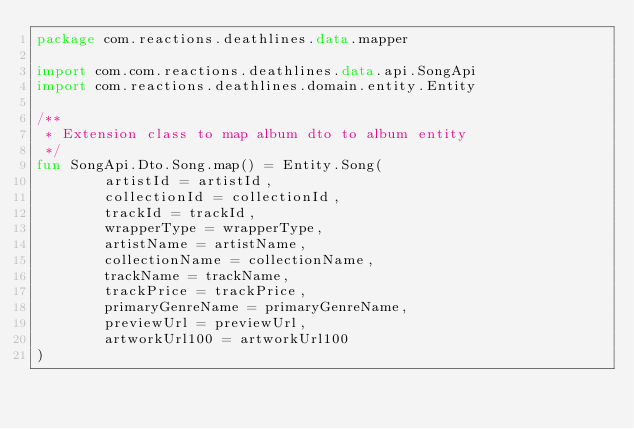<code> <loc_0><loc_0><loc_500><loc_500><_Kotlin_>package com.reactions.deathlines.data.mapper

import com.com.reactions.deathlines.data.api.SongApi
import com.reactions.deathlines.domain.entity.Entity

/**
 * Extension class to map album dto to album entity
 */
fun SongApi.Dto.Song.map() = Entity.Song(
        artistId = artistId,
        collectionId = collectionId,
        trackId = trackId,
        wrapperType = wrapperType,
        artistName = artistName,
        collectionName = collectionName,
        trackName = trackName,
        trackPrice = trackPrice,
        primaryGenreName = primaryGenreName,
        previewUrl = previewUrl,
        artworkUrl100 = artworkUrl100
)</code> 